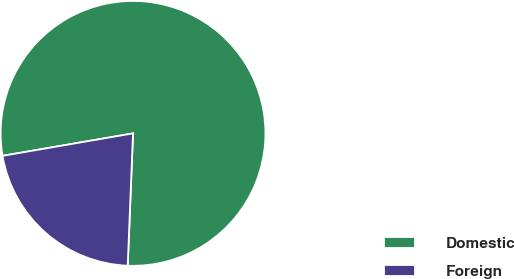<chart> <loc_0><loc_0><loc_500><loc_500><pie_chart><fcel>Domestic<fcel>Foreign<nl><fcel>78.35%<fcel>21.65%<nl></chart> 